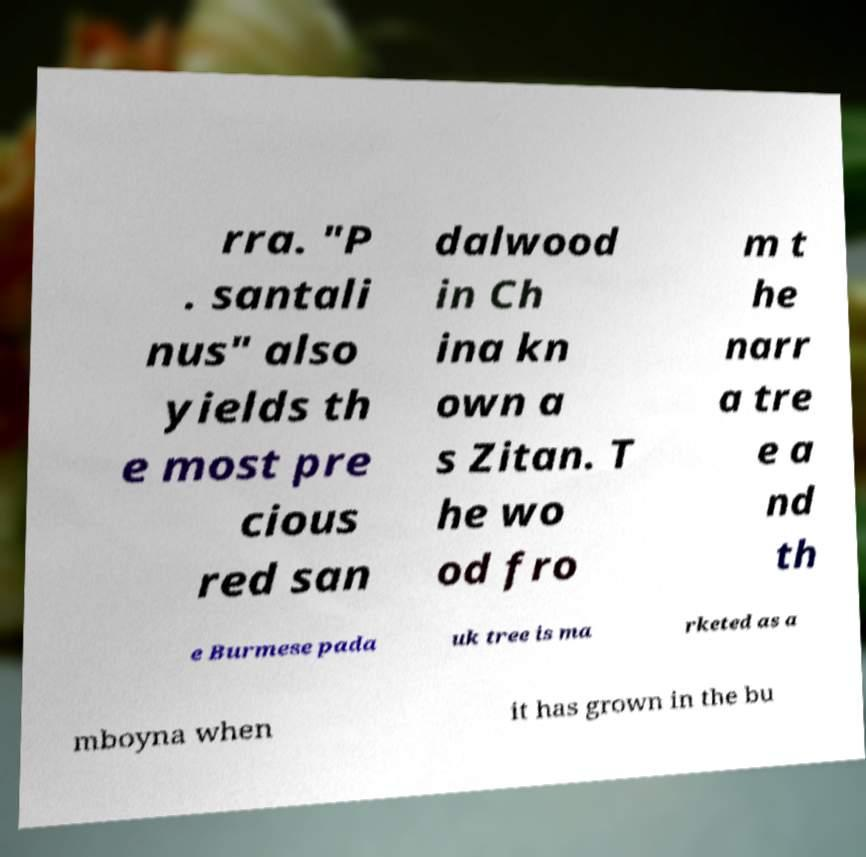Can you accurately transcribe the text from the provided image for me? rra. "P . santali nus" also yields th e most pre cious red san dalwood in Ch ina kn own a s Zitan. T he wo od fro m t he narr a tre e a nd th e Burmese pada uk tree is ma rketed as a mboyna when it has grown in the bu 